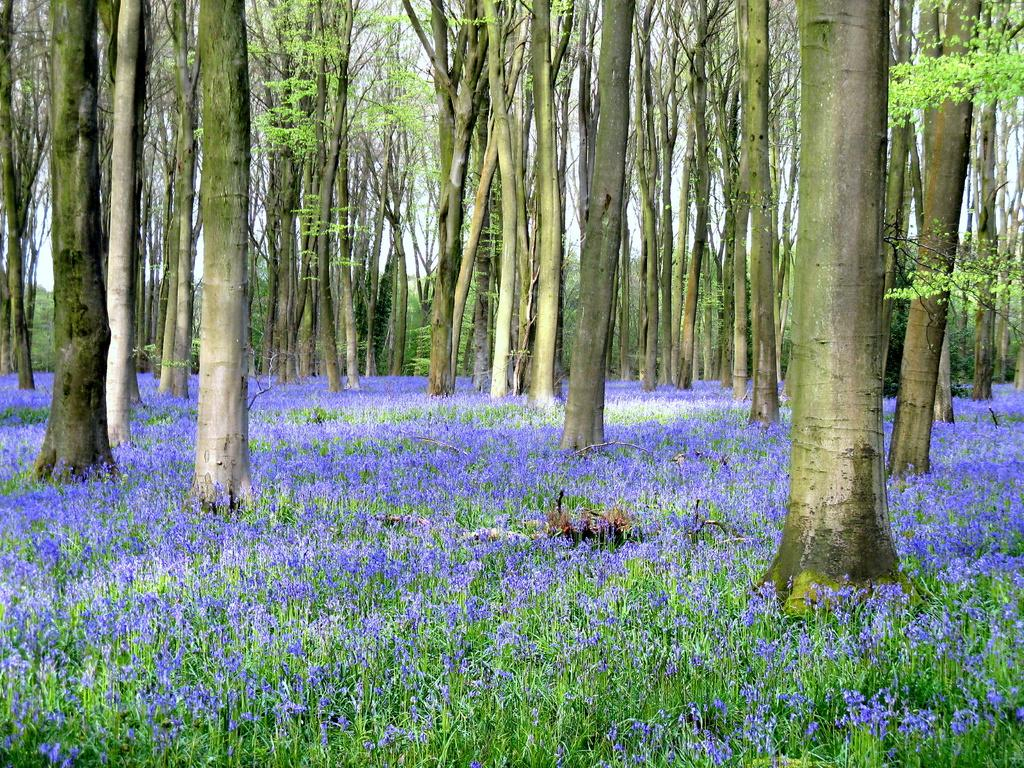What is the primary feature of the image? There are many trees in the image. What other types of vegetation can be seen on the ground in the image? There are flowers and plants on the ground in the image. How many lizards can be seen climbing the trees in the image? There are no lizards visible in the image; it only features trees, flowers, and plants. What type of weather is occurring during the rainstorm in the image? There is no rainstorm present in the image; it is a scene with trees, flowers, and plants. 